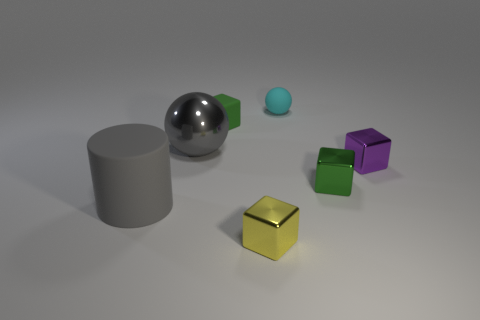Subtract all green blocks. How many were subtracted if there are1green blocks left? 1 Subtract all tiny green metallic blocks. How many blocks are left? 3 Add 2 tiny purple shiny things. How many objects exist? 9 Subtract all green cubes. How many cubes are left? 2 Subtract all red balls. Subtract all cyan cylinders. How many balls are left? 2 Subtract all gray cylinders. How many gray balls are left? 1 Subtract all small cyan objects. Subtract all tiny matte spheres. How many objects are left? 5 Add 7 purple objects. How many purple objects are left? 8 Add 2 gray metal cubes. How many gray metal cubes exist? 2 Subtract 0 purple cylinders. How many objects are left? 7 